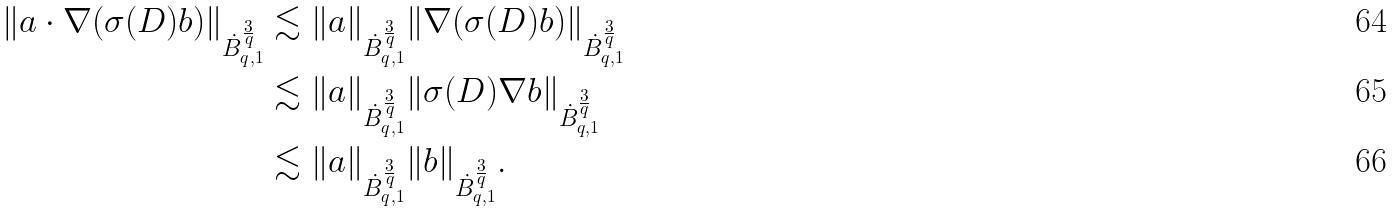Convert formula to latex. <formula><loc_0><loc_0><loc_500><loc_500>\| a \cdot \nabla ( \sigma ( D ) b ) \| _ { \dot { B } ^ { \frac { 3 } { q } } _ { q , 1 } } & \lesssim \| a \| _ { \dot { B } ^ { \frac { 3 } { q } } _ { q , 1 } } \| \nabla ( \sigma ( D ) b ) \| _ { \dot { B } ^ { \frac { 3 } { q } } _ { q , 1 } } \\ & \lesssim \| a \| _ { \dot { B } ^ { \frac { 3 } { q } } _ { q , 1 } } \| \sigma ( D ) \nabla b \| _ { \dot { B } ^ { \frac { 3 } { q } } _ { q , 1 } } \\ & \lesssim \| a \| _ { \dot { B } ^ { \frac { 3 } { q } } _ { q , 1 } } \| b \| _ { \dot { B } ^ { \frac { 3 } { q } } _ { q , 1 } } .</formula> 